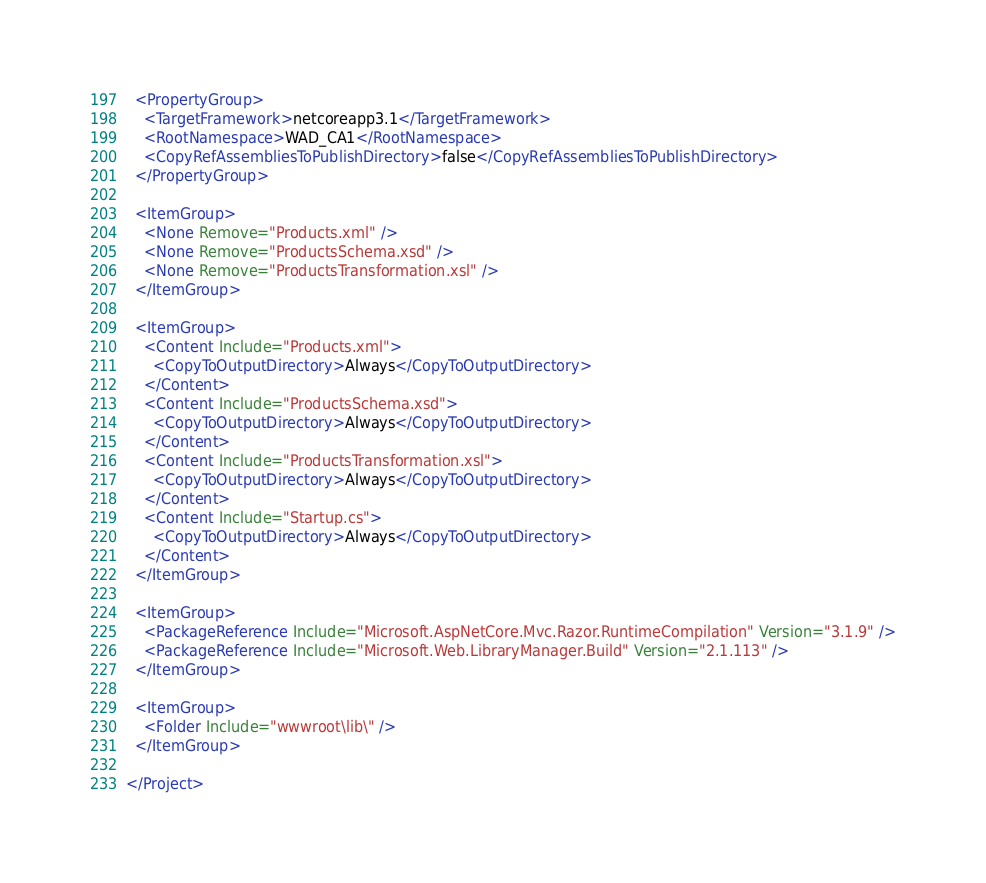<code> <loc_0><loc_0><loc_500><loc_500><_XML_>  <PropertyGroup>
    <TargetFramework>netcoreapp3.1</TargetFramework>
    <RootNamespace>WAD_CA1</RootNamespace>
    <CopyRefAssembliesToPublishDirectory>false</CopyRefAssembliesToPublishDirectory>
  </PropertyGroup>

  <ItemGroup>
    <None Remove="Products.xml" />
    <None Remove="ProductsSchema.xsd" />
    <None Remove="ProductsTransformation.xsl" />
  </ItemGroup>

  <ItemGroup>
    <Content Include="Products.xml">
      <CopyToOutputDirectory>Always</CopyToOutputDirectory>
    </Content>
    <Content Include="ProductsSchema.xsd">
      <CopyToOutputDirectory>Always</CopyToOutputDirectory>
    </Content>
    <Content Include="ProductsTransformation.xsl">
      <CopyToOutputDirectory>Always</CopyToOutputDirectory>
    </Content>
    <Content Include="Startup.cs">
      <CopyToOutputDirectory>Always</CopyToOutputDirectory>
    </Content>
  </ItemGroup>

  <ItemGroup>
    <PackageReference Include="Microsoft.AspNetCore.Mvc.Razor.RuntimeCompilation" Version="3.1.9" />
    <PackageReference Include="Microsoft.Web.LibraryManager.Build" Version="2.1.113" />
  </ItemGroup>

  <ItemGroup>
    <Folder Include="wwwroot\lib\" />
  </ItemGroup>

</Project>
</code> 